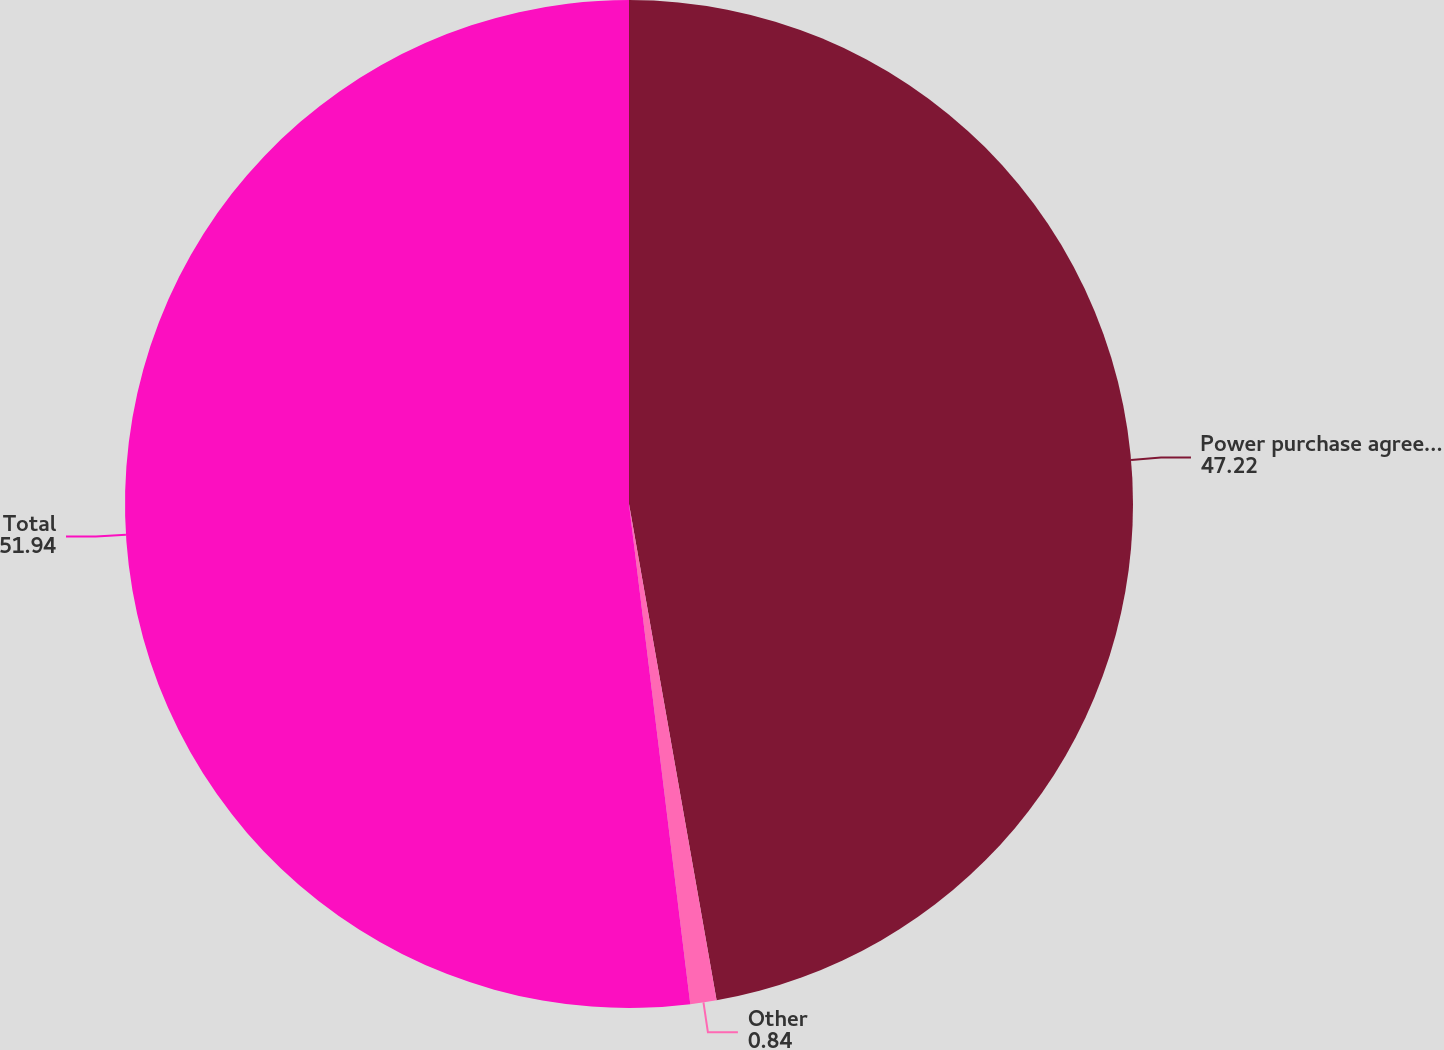<chart> <loc_0><loc_0><loc_500><loc_500><pie_chart><fcel>Power purchase agreement of an<fcel>Other<fcel>Total<nl><fcel>47.22%<fcel>0.84%<fcel>51.94%<nl></chart> 